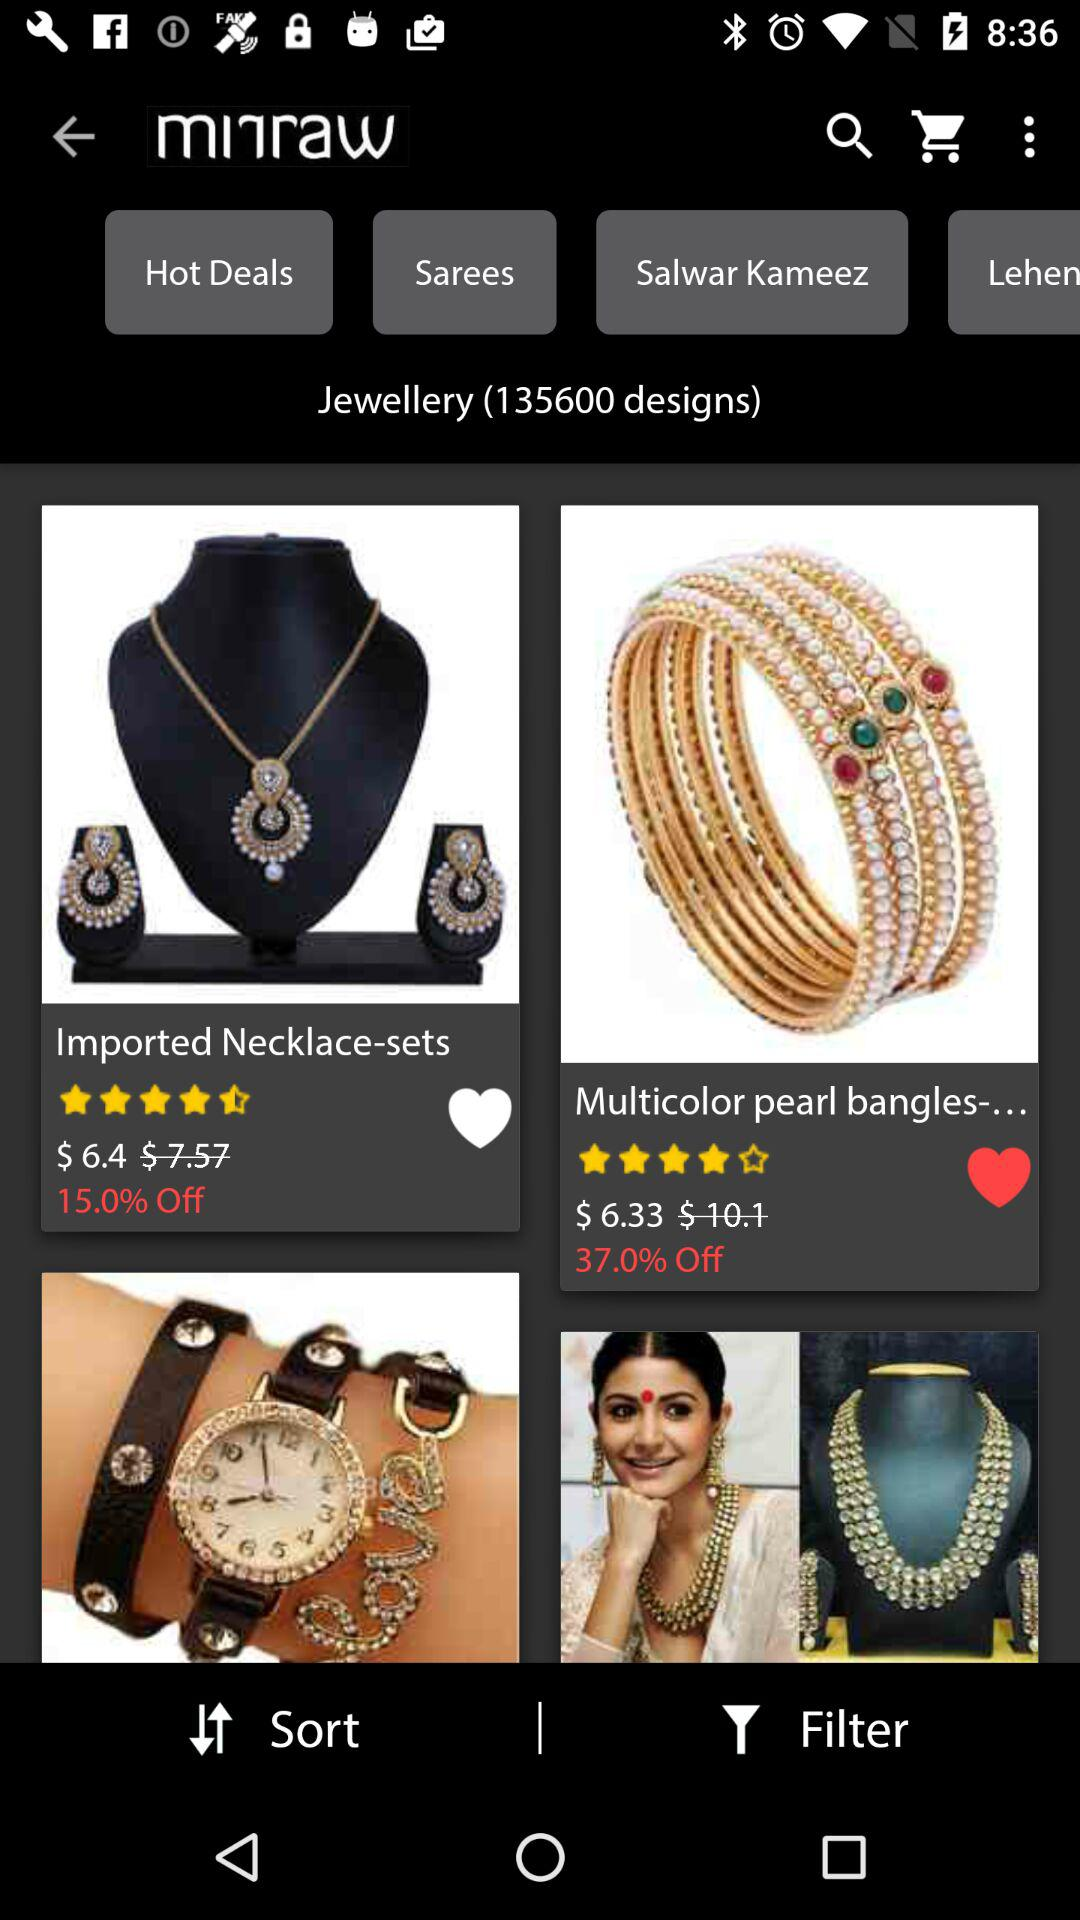What is the rating of the necklace sets? The rating is 4.5 stars. 